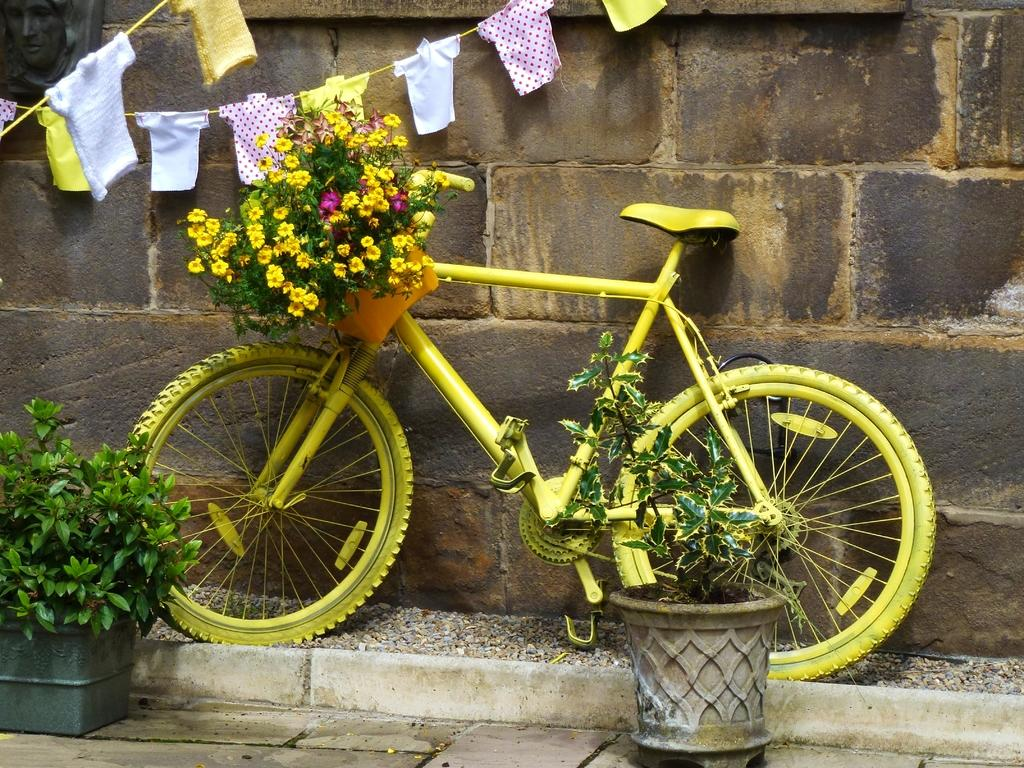What type of vehicle is in the image? There is a yellow bicycle in the image. What feature does the bicycle have? The bicycle has a basket. What is inside the basket? The basket contains flowers. What else can be seen in the image besides the bicycle? There are plants and clothes hung on ropes in the image. What is the background of the image? There is a wall in the image. How many cents are visible on the wall in the image? There are no cents visible on the wall in the image. What type of lizards can be seen crawling on the bicycle in the image? There are no lizards present in the image. 